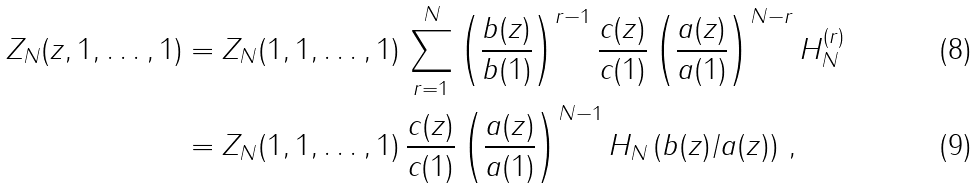Convert formula to latex. <formula><loc_0><loc_0><loc_500><loc_500>Z _ { N } ( z , 1 , \dots , 1 ) & = Z _ { N } ( 1 , 1 , \dots , 1 ) \, \sum _ { r = 1 } ^ { N } \left ( \frac { b ( z ) } { b ( 1 ) } \right ) ^ { r - 1 } \frac { c ( z ) } { c ( 1 ) } \left ( \frac { a ( z ) } { a ( 1 ) } \right ) ^ { N - r } H _ { N } ^ { ( r ) } \\ & = Z _ { N } ( 1 , 1 , \dots , 1 ) \, \frac { c ( z ) } { c ( 1 ) } \left ( \frac { a ( z ) } { a ( 1 ) } \right ) ^ { N - 1 } H _ { N } \left ( b ( z ) / a ( z ) \right ) \, ,</formula> 